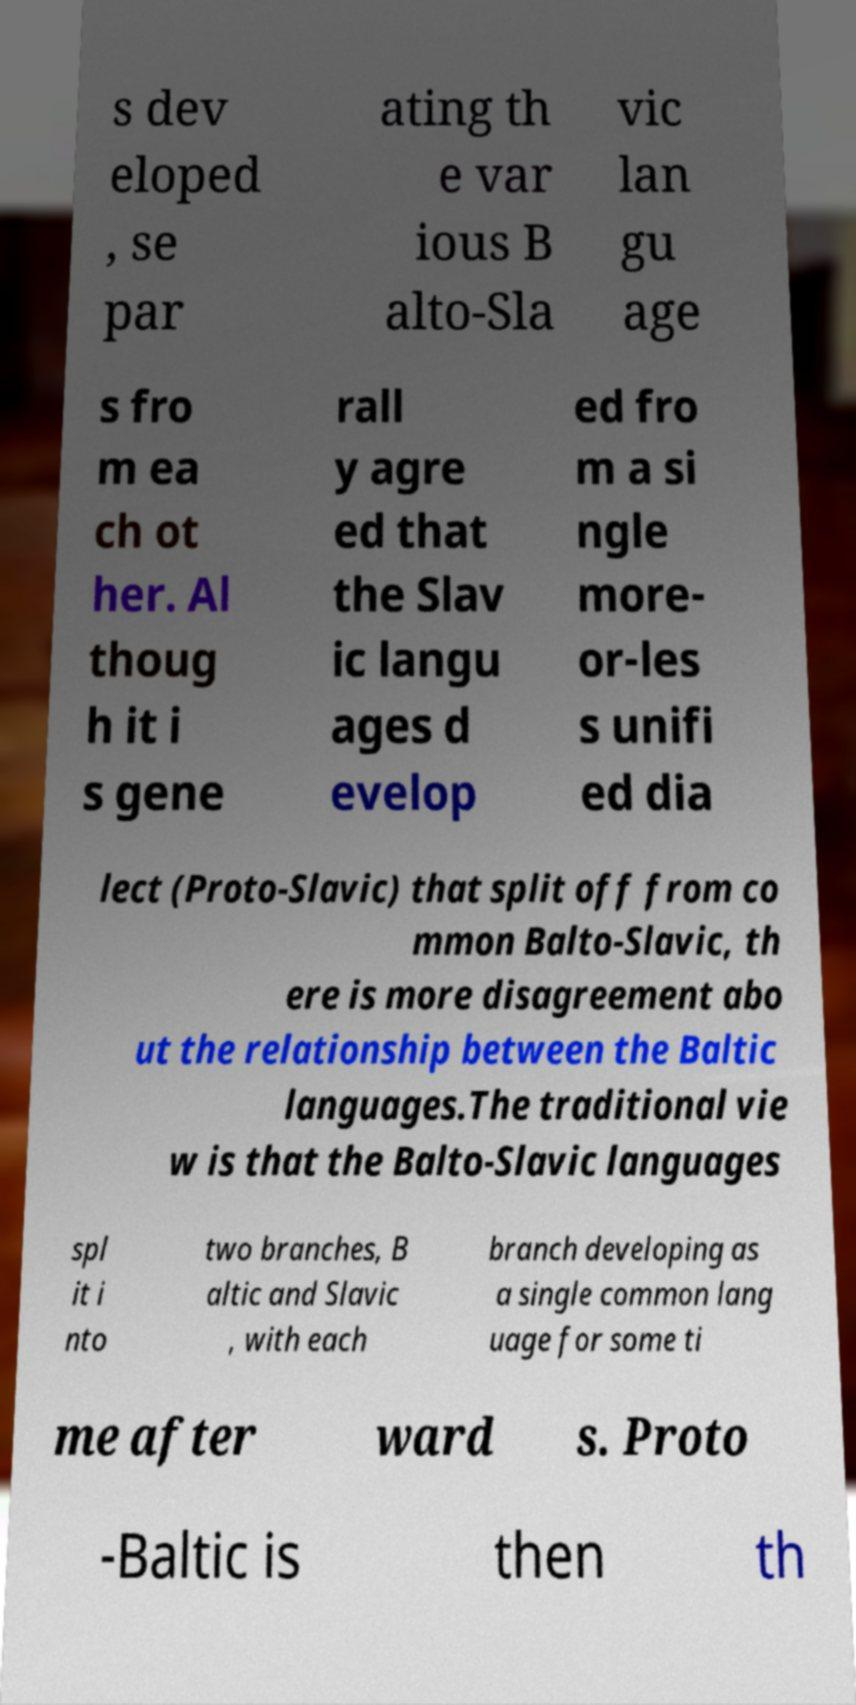Could you extract and type out the text from this image? s dev eloped , se par ating th e var ious B alto-Sla vic lan gu age s fro m ea ch ot her. Al thoug h it i s gene rall y agre ed that the Slav ic langu ages d evelop ed fro m a si ngle more- or-les s unifi ed dia lect (Proto-Slavic) that split off from co mmon Balto-Slavic, th ere is more disagreement abo ut the relationship between the Baltic languages.The traditional vie w is that the Balto-Slavic languages spl it i nto two branches, B altic and Slavic , with each branch developing as a single common lang uage for some ti me after ward s. Proto -Baltic is then th 